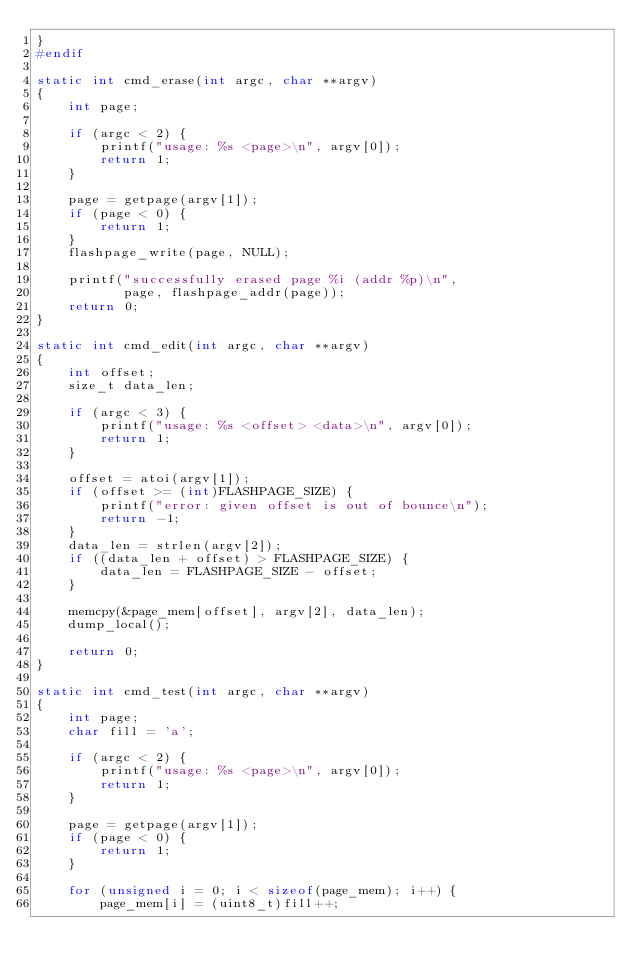Convert code to text. <code><loc_0><loc_0><loc_500><loc_500><_C_>}
#endif

static int cmd_erase(int argc, char **argv)
{
    int page;

    if (argc < 2) {
        printf("usage: %s <page>\n", argv[0]);
        return 1;
    }

    page = getpage(argv[1]);
    if (page < 0) {
        return 1;
    }
    flashpage_write(page, NULL);

    printf("successfully erased page %i (addr %p)\n",
           page, flashpage_addr(page));
    return 0;
}

static int cmd_edit(int argc, char **argv)
{
    int offset;
    size_t data_len;

    if (argc < 3) {
        printf("usage: %s <offset> <data>\n", argv[0]);
        return 1;
    }

    offset = atoi(argv[1]);
    if (offset >= (int)FLASHPAGE_SIZE) {
        printf("error: given offset is out of bounce\n");
        return -1;
    }
    data_len = strlen(argv[2]);
    if ((data_len + offset) > FLASHPAGE_SIZE) {
        data_len = FLASHPAGE_SIZE - offset;
    }

    memcpy(&page_mem[offset], argv[2], data_len);
    dump_local();

    return 0;
}

static int cmd_test(int argc, char **argv)
{
    int page;
    char fill = 'a';

    if (argc < 2) {
        printf("usage: %s <page>\n", argv[0]);
        return 1;
    }

    page = getpage(argv[1]);
    if (page < 0) {
        return 1;
    }

    for (unsigned i = 0; i < sizeof(page_mem); i++) {
        page_mem[i] = (uint8_t)fill++;</code> 